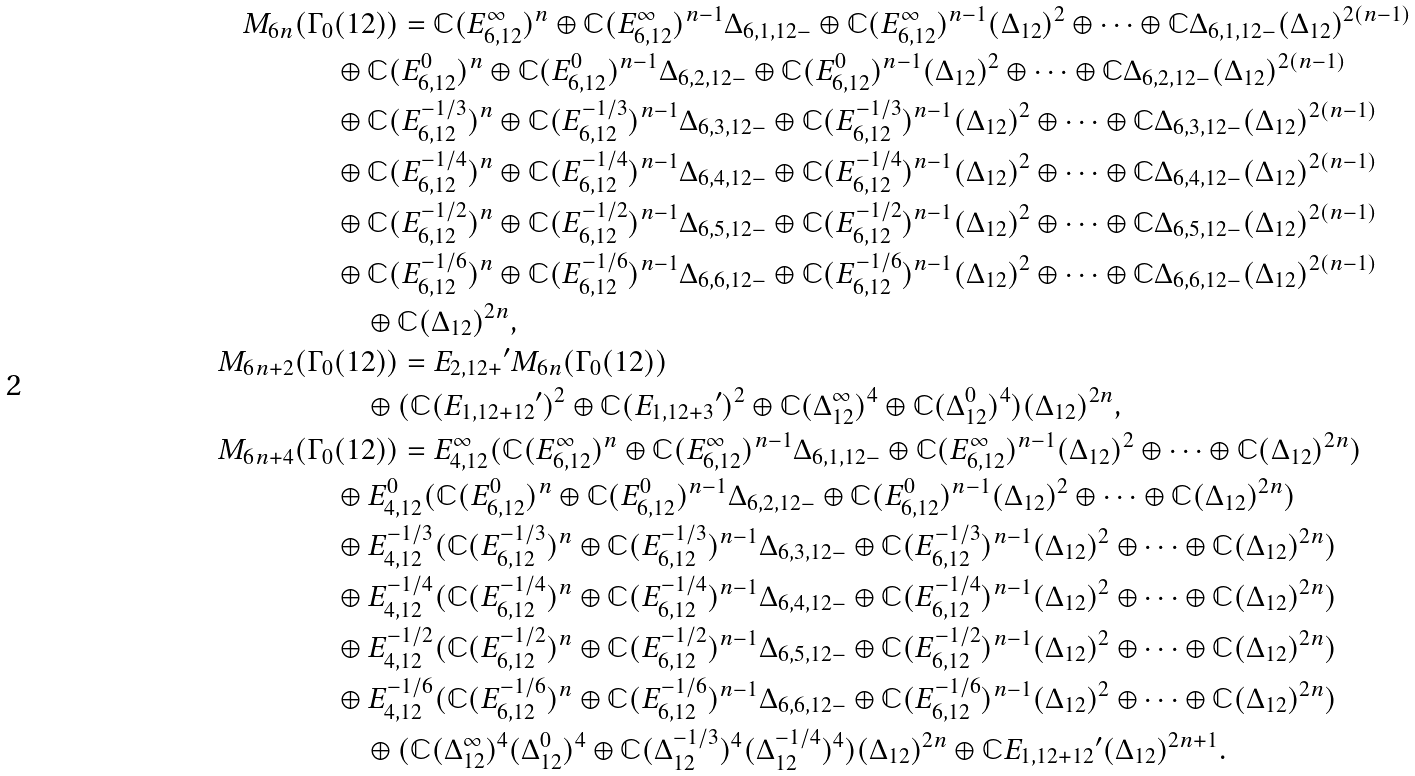Convert formula to latex. <formula><loc_0><loc_0><loc_500><loc_500>M _ { 6 n } ( \Gamma _ { 0 } & ( 1 2 ) ) = \mathbb { C } ( E _ { 6 , 1 2 } ^ { \infty } ) ^ { n } \oplus \mathbb { C } ( E _ { 6 , 1 2 } ^ { \infty } ) ^ { n - 1 } \Delta _ { 6 , 1 , 1 2 - } \oplus \mathbb { C } ( E _ { 6 , 1 2 } ^ { \infty } ) ^ { n - 1 } ( \Delta _ { 1 2 } ) ^ { 2 } \oplus \cdots \oplus \mathbb { C } \Delta _ { 6 , 1 , 1 2 - } ( \Delta _ { 1 2 } ) ^ { 2 ( n - 1 ) } \\ & \oplus \mathbb { C } ( E _ { 6 , 1 2 } ^ { 0 } ) ^ { n } \oplus \mathbb { C } ( E _ { 6 , 1 2 } ^ { 0 } ) ^ { n - 1 } \Delta _ { 6 , 2 , 1 2 - } \oplus \mathbb { C } ( E _ { 6 , 1 2 } ^ { 0 } ) ^ { n - 1 } ( \Delta _ { 1 2 } ) ^ { 2 } \oplus \cdots \oplus \mathbb { C } \Delta _ { 6 , 2 , 1 2 - } ( \Delta _ { 1 2 } ) ^ { 2 ( n - 1 ) } \\ & \oplus \mathbb { C } ( E _ { 6 , 1 2 } ^ { - 1 / 3 } ) ^ { n } \oplus \mathbb { C } ( E _ { 6 , 1 2 } ^ { - 1 / 3 } ) ^ { n - 1 } \Delta _ { 6 , 3 , 1 2 - } \oplus \mathbb { C } ( E _ { 6 , 1 2 } ^ { - 1 / 3 } ) ^ { n - 1 } ( \Delta _ { 1 2 } ) ^ { 2 } \oplus \cdots \oplus \mathbb { C } \Delta _ { 6 , 3 , 1 2 - } ( \Delta _ { 1 2 } ) ^ { 2 ( n - 1 ) } \\ & \oplus \mathbb { C } ( E _ { 6 , 1 2 } ^ { - 1 / 4 } ) ^ { n } \oplus \mathbb { C } ( E _ { 6 , 1 2 } ^ { - 1 / 4 } ) ^ { n - 1 } \Delta _ { 6 , 4 , 1 2 - } \oplus \mathbb { C } ( E _ { 6 , 1 2 } ^ { - 1 / 4 } ) ^ { n - 1 } ( \Delta _ { 1 2 } ) ^ { 2 } \oplus \cdots \oplus \mathbb { C } \Delta _ { 6 , 4 , 1 2 - } ( \Delta _ { 1 2 } ) ^ { 2 ( n - 1 ) } \\ & \oplus \mathbb { C } ( E _ { 6 , 1 2 } ^ { - 1 / 2 } ) ^ { n } \oplus \mathbb { C } ( E _ { 6 , 1 2 } ^ { - 1 / 2 } ) ^ { n - 1 } \Delta _ { 6 , 5 , 1 2 - } \oplus \mathbb { C } ( E _ { 6 , 1 2 } ^ { - 1 / 2 } ) ^ { n - 1 } ( \Delta _ { 1 2 } ) ^ { 2 } \oplus \cdots \oplus \mathbb { C } \Delta _ { 6 , 5 , 1 2 - } ( \Delta _ { 1 2 } ) ^ { 2 ( n - 1 ) } \\ & \oplus \mathbb { C } ( E _ { 6 , 1 2 } ^ { - 1 / 6 } ) ^ { n } \oplus \mathbb { C } ( E _ { 6 , 1 2 } ^ { - 1 / 6 } ) ^ { n - 1 } \Delta _ { 6 , 6 , 1 2 - } \oplus \mathbb { C } ( E _ { 6 , 1 2 } ^ { - 1 / 6 } ) ^ { n - 1 } ( \Delta _ { 1 2 } ) ^ { 2 } \oplus \cdots \oplus \mathbb { C } \Delta _ { 6 , 6 , 1 2 - } ( \Delta _ { 1 2 } ) ^ { 2 ( n - 1 ) } \\ & \quad \oplus \mathbb { C } ( \Delta _ { 1 2 } ) ^ { 2 n } , \\ M _ { 6 n + 2 } ( \Gamma _ { 0 } & ( 1 2 ) ) = { E _ { 2 , 1 2 + } } ^ { \prime } M _ { 6 n } ( \Gamma _ { 0 } ( 1 2 ) ) \\ & \quad \oplus ( \mathbb { C } ( { E _ { 1 , 1 2 + 1 2 } } ^ { \prime } ) ^ { 2 } \oplus \mathbb { C } ( { E _ { 1 , 1 2 + 3 } } ^ { \prime } ) ^ { 2 } \oplus \mathbb { C } ( \Delta _ { 1 2 } ^ { \infty } ) ^ { 4 } \oplus \mathbb { C } ( \Delta _ { 1 2 } ^ { 0 } ) ^ { 4 } ) ( \Delta _ { 1 2 } ) ^ { 2 n } , \\ M _ { 6 n + 4 } ( \Gamma _ { 0 } & ( 1 2 ) ) = E _ { 4 , 1 2 } ^ { \infty } ( \mathbb { C } ( E _ { 6 , 1 2 } ^ { \infty } ) ^ { n } \oplus \mathbb { C } ( E _ { 6 , 1 2 } ^ { \infty } ) ^ { n - 1 } \Delta _ { 6 , 1 , 1 2 - } \oplus \mathbb { C } ( E _ { 6 , 1 2 } ^ { \infty } ) ^ { n - 1 } ( \Delta _ { 1 2 } ) ^ { 2 } \oplus \cdots \oplus \mathbb { C } ( \Delta _ { 1 2 } ) ^ { 2 n } ) \\ & \oplus E _ { 4 , 1 2 } ^ { 0 } ( \mathbb { C } ( E _ { 6 , 1 2 } ^ { 0 } ) ^ { n } \oplus \mathbb { C } ( E _ { 6 , 1 2 } ^ { 0 } ) ^ { n - 1 } \Delta _ { 6 , 2 , 1 2 - } \oplus \mathbb { C } ( E _ { 6 , 1 2 } ^ { 0 } ) ^ { n - 1 } ( \Delta _ { 1 2 } ) ^ { 2 } \oplus \cdots \oplus \mathbb { C } ( \Delta _ { 1 2 } ) ^ { 2 n } ) \\ & \oplus E _ { 4 , 1 2 } ^ { - 1 / 3 } ( \mathbb { C } ( E _ { 6 , 1 2 } ^ { - 1 / 3 } ) ^ { n } \oplus \mathbb { C } ( E _ { 6 , 1 2 } ^ { - 1 / 3 } ) ^ { n - 1 } \Delta _ { 6 , 3 , 1 2 - } \oplus \mathbb { C } ( E _ { 6 , 1 2 } ^ { - 1 / 3 } ) ^ { n - 1 } ( \Delta _ { 1 2 } ) ^ { 2 } \oplus \cdots \oplus \mathbb { C } ( \Delta _ { 1 2 } ) ^ { 2 n } ) \\ & \oplus E _ { 4 , 1 2 } ^ { - 1 / 4 } ( \mathbb { C } ( E _ { 6 , 1 2 } ^ { - 1 / 4 } ) ^ { n } \oplus \mathbb { C } ( E _ { 6 , 1 2 } ^ { - 1 / 4 } ) ^ { n - 1 } \Delta _ { 6 , 4 , 1 2 - } \oplus \mathbb { C } ( E _ { 6 , 1 2 } ^ { - 1 / 4 } ) ^ { n - 1 } ( \Delta _ { 1 2 } ) ^ { 2 } \oplus \cdots \oplus \mathbb { C } ( \Delta _ { 1 2 } ) ^ { 2 n } ) \\ & \oplus E _ { 4 , 1 2 } ^ { - 1 / 2 } ( \mathbb { C } ( E _ { 6 , 1 2 } ^ { - 1 / 2 } ) ^ { n } \oplus \mathbb { C } ( E _ { 6 , 1 2 } ^ { - 1 / 2 } ) ^ { n - 1 } \Delta _ { 6 , 5 , 1 2 - } \oplus \mathbb { C } ( E _ { 6 , 1 2 } ^ { - 1 / 2 } ) ^ { n - 1 } ( \Delta _ { 1 2 } ) ^ { 2 } \oplus \cdots \oplus \mathbb { C } ( \Delta _ { 1 2 } ) ^ { 2 n } ) \\ & \oplus E _ { 4 , 1 2 } ^ { - 1 / 6 } ( \mathbb { C } ( E _ { 6 , 1 2 } ^ { - 1 / 6 } ) ^ { n } \oplus \mathbb { C } ( E _ { 6 , 1 2 } ^ { - 1 / 6 } ) ^ { n - 1 } \Delta _ { 6 , 6 , 1 2 - } \oplus \mathbb { C } ( E _ { 6 , 1 2 } ^ { - 1 / 6 } ) ^ { n - 1 } ( \Delta _ { 1 2 } ) ^ { 2 } \oplus \cdots \oplus \mathbb { C } ( \Delta _ { 1 2 } ) ^ { 2 n } ) \\ & \quad \oplus ( \mathbb { C } ( \Delta _ { 1 2 } ^ { \infty } ) ^ { 4 } ( \Delta _ { 1 2 } ^ { 0 } ) ^ { 4 } \oplus \mathbb { C } ( \Delta _ { 1 2 } ^ { - 1 / 3 } ) ^ { 4 } ( \Delta _ { 1 2 } ^ { - 1 / 4 } ) ^ { 4 } ) ( \Delta _ { 1 2 } ) ^ { 2 n } \oplus \mathbb { C } { E _ { 1 , 1 2 + 1 2 } } ^ { \prime } ( \Delta _ { 1 2 } ) ^ { 2 n + 1 } .</formula> 